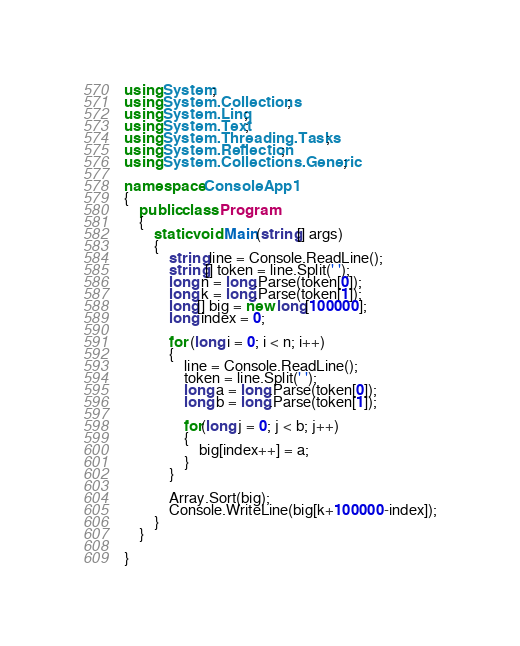<code> <loc_0><loc_0><loc_500><loc_500><_C#_>using System;
using System.Collections;
using System.Linq;
using System.Text;
using System.Threading.Tasks;
using System.Reflection;
using System.Collections.Generic;

namespace ConsoleApp1
{
    public class Program
    {
        static void Main(string[] args)
        {
            string line = Console.ReadLine();
            string[] token = line.Split(' ');
            long n = long.Parse(token[0]);
            long k = long.Parse(token[1]);
            long[] big = new long[100000];
            long index = 0;

            for (long i = 0; i < n; i++)
            {
                line = Console.ReadLine();
                token = line.Split(' ');
                long a = long.Parse(token[0]);
                long b = long.Parse(token[1]);

                for(long j = 0; j < b; j++)
                {
                    big[index++] = a;
                }
            }

            Array.Sort(big);
            Console.WriteLine(big[k+100000-index]);
        }
    }

}
</code> 